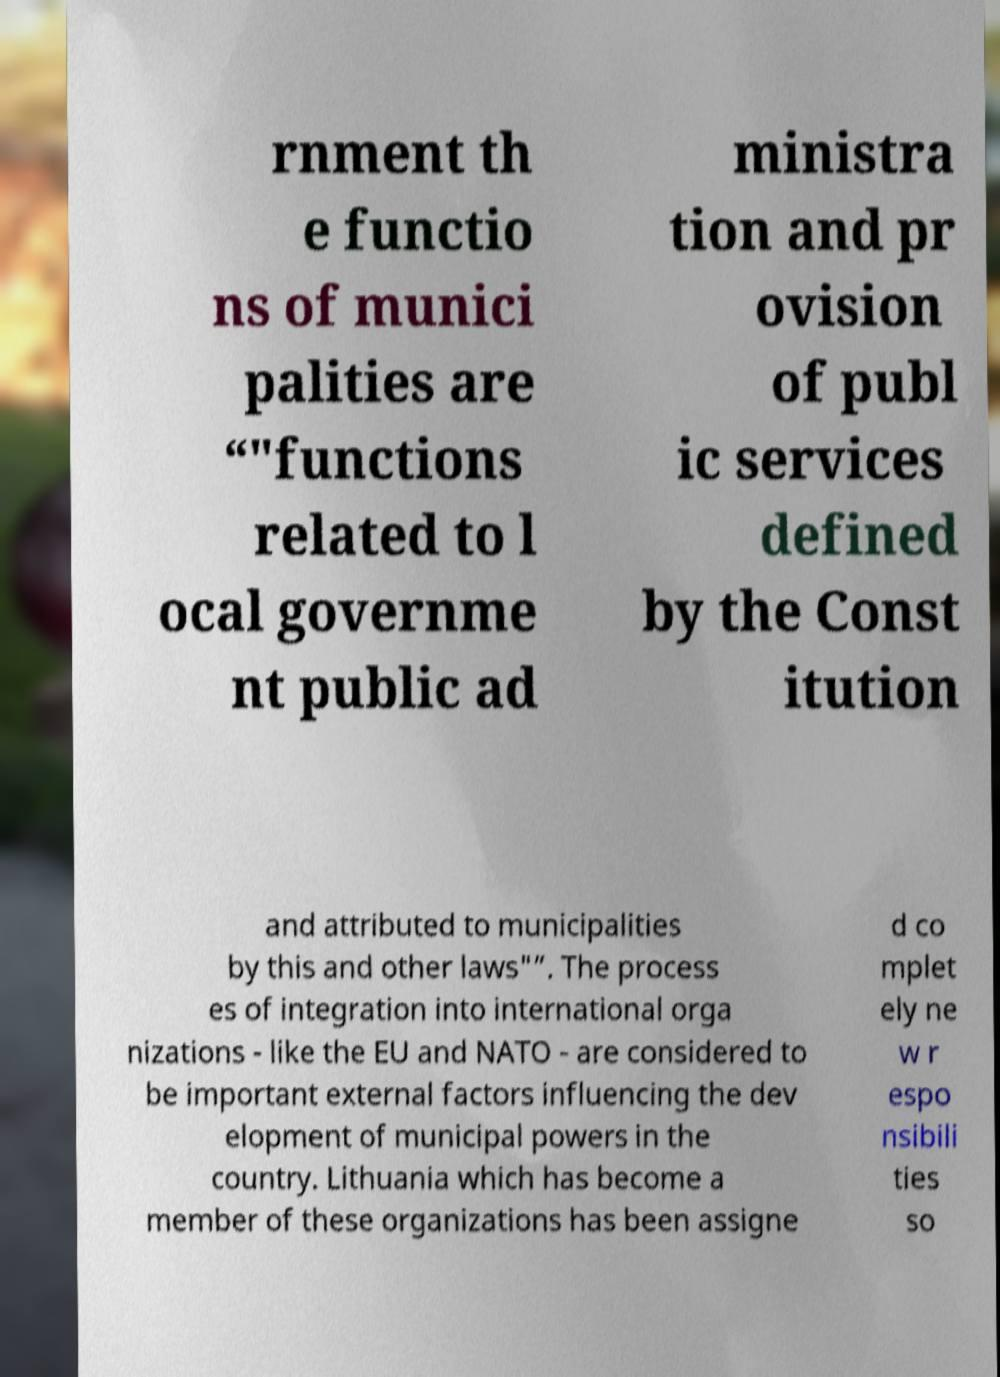What messages or text are displayed in this image? I need them in a readable, typed format. rnment th e functio ns of munici palities are “"functions related to l ocal governme nt public ad ministra tion and pr ovision of publ ic services defined by the Const itution and attributed to municipalities by this and other laws"”. The process es of integration into international orga nizations - like the EU and NATO - are considered to be important external factors influencing the dev elopment of municipal powers in the country. Lithuania which has become a member of these organizations has been assigne d co mplet ely ne w r espo nsibili ties so 